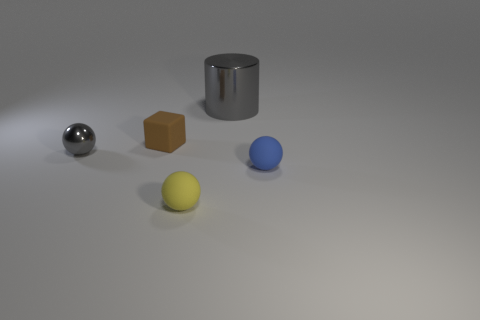What number of cubes are the same material as the brown thing?
Ensure brevity in your answer.  0. How many metallic objects are either green cylinders or blue objects?
Your answer should be very brief. 0. What is the material of the gray sphere that is the same size as the brown cube?
Make the answer very short. Metal. Are there any blue objects made of the same material as the brown thing?
Offer a very short reply. Yes. The gray object that is to the left of the rubber object to the left of the small matte ball that is to the left of the big gray metal thing is what shape?
Your response must be concise. Sphere. There is a gray shiny ball; is its size the same as the thing in front of the blue sphere?
Give a very brief answer. Yes. There is a object that is to the right of the yellow sphere and in front of the gray shiny cylinder; what shape is it?
Keep it short and to the point. Sphere. What number of tiny objects are either blue balls or matte balls?
Provide a short and direct response. 2. Is the number of balls on the right side of the large gray object the same as the number of tiny matte objects behind the small gray metal thing?
Ensure brevity in your answer.  Yes. What number of other objects are there of the same color as the cylinder?
Provide a succinct answer. 1. 